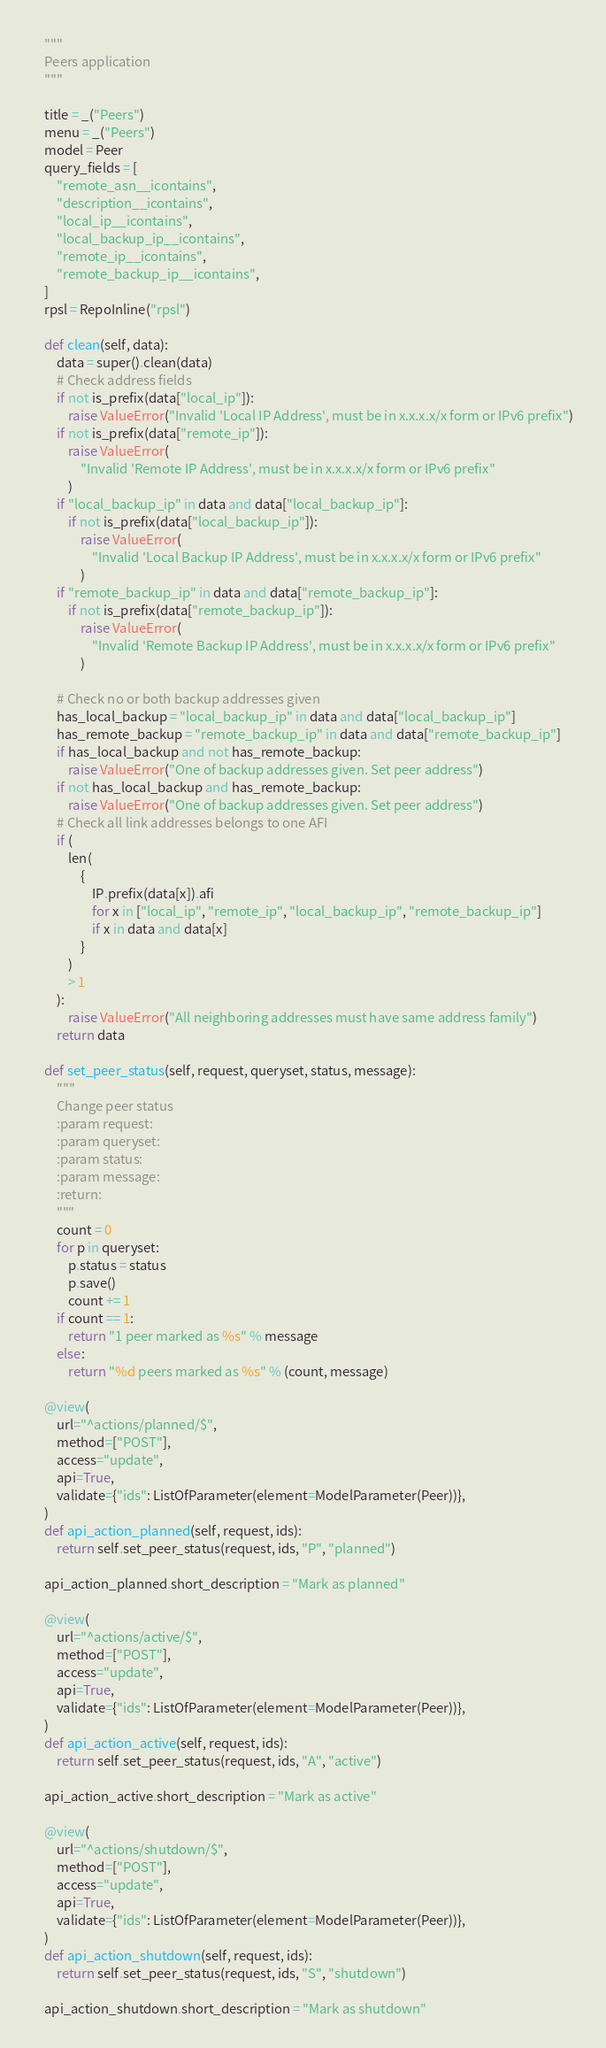<code> <loc_0><loc_0><loc_500><loc_500><_Python_>    """
    Peers application
    """

    title = _("Peers")
    menu = _("Peers")
    model = Peer
    query_fields = [
        "remote_asn__icontains",
        "description__icontains",
        "local_ip__icontains",
        "local_backup_ip__icontains",
        "remote_ip__icontains",
        "remote_backup_ip__icontains",
    ]
    rpsl = RepoInline("rpsl")

    def clean(self, data):
        data = super().clean(data)
        # Check address fields
        if not is_prefix(data["local_ip"]):
            raise ValueError("Invalid 'Local IP Address', must be in x.x.x.x/x form or IPv6 prefix")
        if not is_prefix(data["remote_ip"]):
            raise ValueError(
                "Invalid 'Remote IP Address', must be in x.x.x.x/x form or IPv6 prefix"
            )
        if "local_backup_ip" in data and data["local_backup_ip"]:
            if not is_prefix(data["local_backup_ip"]):
                raise ValueError(
                    "Invalid 'Local Backup IP Address', must be in x.x.x.x/x form or IPv6 prefix"
                )
        if "remote_backup_ip" in data and data["remote_backup_ip"]:
            if not is_prefix(data["remote_backup_ip"]):
                raise ValueError(
                    "Invalid 'Remote Backup IP Address', must be in x.x.x.x/x form or IPv6 prefix"
                )

        # Check no or both backup addresses given
        has_local_backup = "local_backup_ip" in data and data["local_backup_ip"]
        has_remote_backup = "remote_backup_ip" in data and data["remote_backup_ip"]
        if has_local_backup and not has_remote_backup:
            raise ValueError("One of backup addresses given. Set peer address")
        if not has_local_backup and has_remote_backup:
            raise ValueError("One of backup addresses given. Set peer address")
        # Check all link addresses belongs to one AFI
        if (
            len(
                {
                    IP.prefix(data[x]).afi
                    for x in ["local_ip", "remote_ip", "local_backup_ip", "remote_backup_ip"]
                    if x in data and data[x]
                }
            )
            > 1
        ):
            raise ValueError("All neighboring addresses must have same address family")
        return data

    def set_peer_status(self, request, queryset, status, message):
        """
        Change peer status
        :param request:
        :param queryset:
        :param status:
        :param message:
        :return:
        """
        count = 0
        for p in queryset:
            p.status = status
            p.save()
            count += 1
        if count == 1:
            return "1 peer marked as %s" % message
        else:
            return "%d peers marked as %s" % (count, message)

    @view(
        url="^actions/planned/$",
        method=["POST"],
        access="update",
        api=True,
        validate={"ids": ListOfParameter(element=ModelParameter(Peer))},
    )
    def api_action_planned(self, request, ids):
        return self.set_peer_status(request, ids, "P", "planned")

    api_action_planned.short_description = "Mark as planned"

    @view(
        url="^actions/active/$",
        method=["POST"],
        access="update",
        api=True,
        validate={"ids": ListOfParameter(element=ModelParameter(Peer))},
    )
    def api_action_active(self, request, ids):
        return self.set_peer_status(request, ids, "A", "active")

    api_action_active.short_description = "Mark as active"

    @view(
        url="^actions/shutdown/$",
        method=["POST"],
        access="update",
        api=True,
        validate={"ids": ListOfParameter(element=ModelParameter(Peer))},
    )
    def api_action_shutdown(self, request, ids):
        return self.set_peer_status(request, ids, "S", "shutdown")

    api_action_shutdown.short_description = "Mark as shutdown"
</code> 